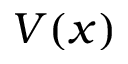Convert formula to latex. <formula><loc_0><loc_0><loc_500><loc_500>V ( x )</formula> 